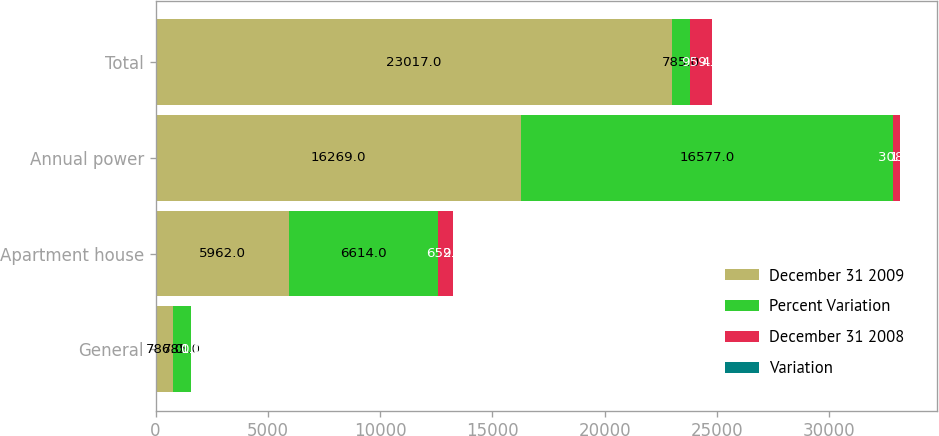<chart> <loc_0><loc_0><loc_500><loc_500><stacked_bar_chart><ecel><fcel>General<fcel>Apartment house<fcel>Annual power<fcel>Total<nl><fcel>December 31 2009<fcel>786<fcel>5962<fcel>16269<fcel>23017<nl><fcel>Percent Variation<fcel>785<fcel>6614<fcel>16577<fcel>785<nl><fcel>December 31 2008<fcel>1<fcel>652<fcel>308<fcel>959<nl><fcel>Variation<fcel>0.1<fcel>9.9<fcel>1.9<fcel>4<nl></chart> 